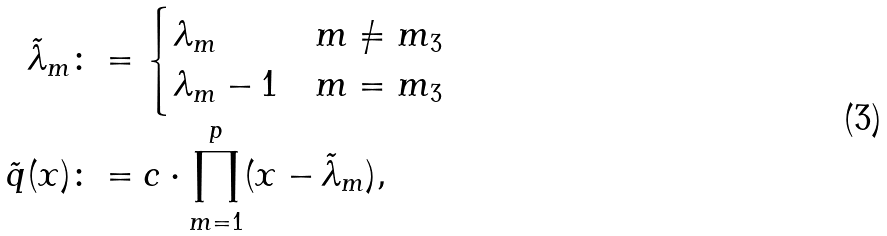Convert formula to latex. <formula><loc_0><loc_0><loc_500><loc_500>\tilde { \lambda } _ { m } & \colon = \begin{cases} \lambda _ { m } & m \ne m _ { 3 } \\ \lambda _ { m } - 1 & m = m _ { 3 } \end{cases} \\ \tilde { q } ( x ) & \colon = c \cdot \prod _ { m = 1 } ^ { p } ( x - \tilde { \lambda } _ { m } ) ,</formula> 